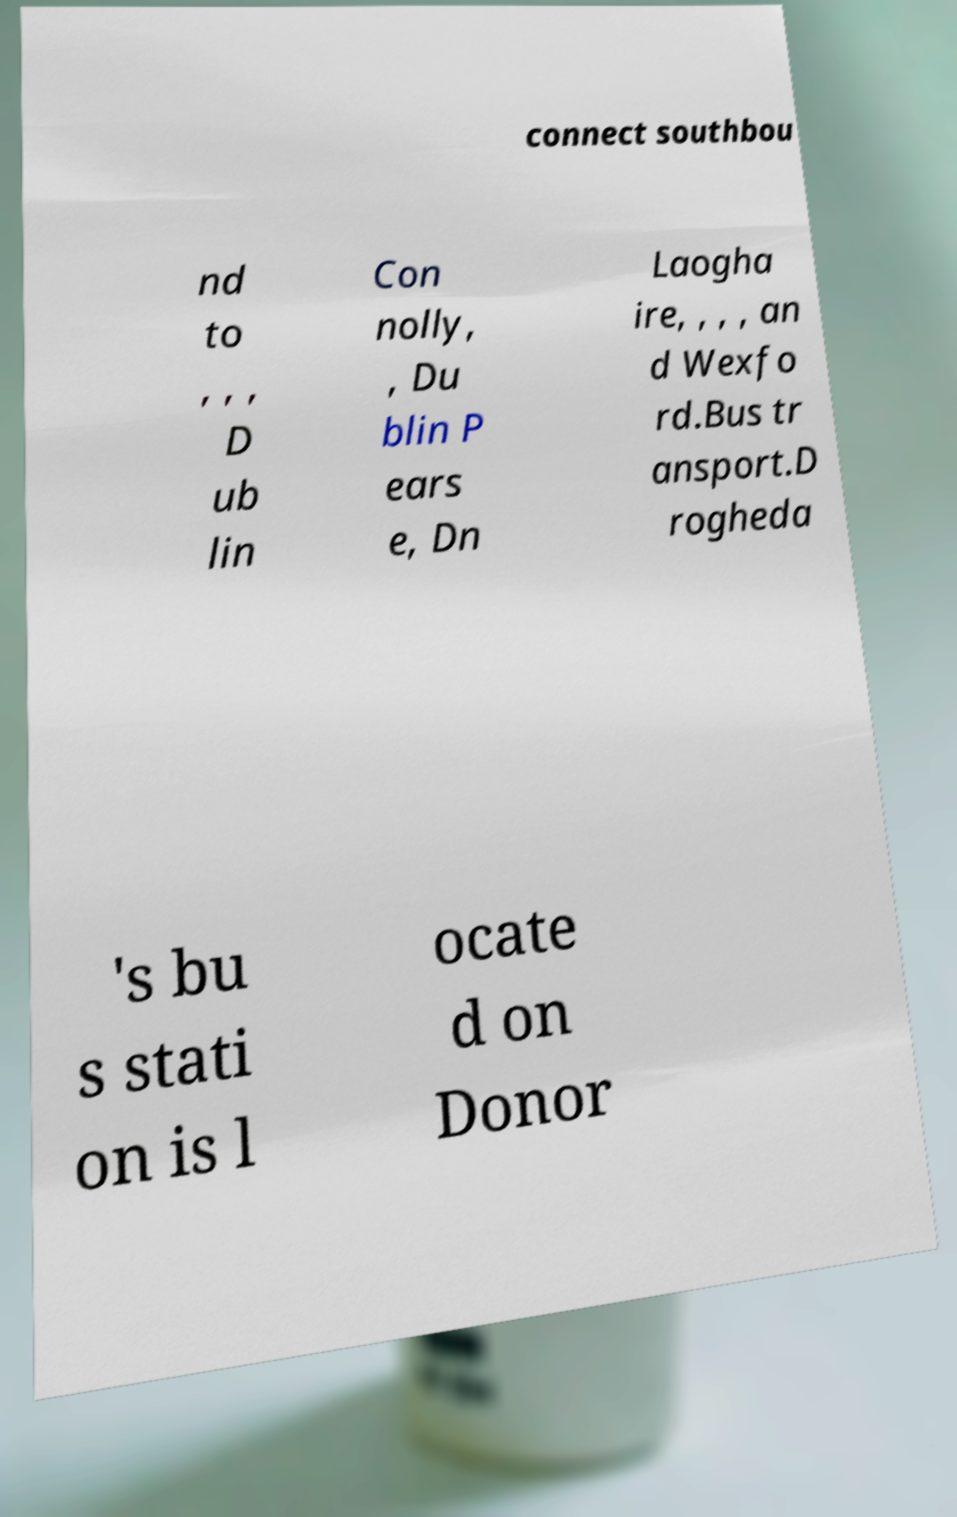What messages or text are displayed in this image? I need them in a readable, typed format. connect southbou nd to , , , D ub lin Con nolly, , Du blin P ears e, Dn Laogha ire, , , , an d Wexfo rd.Bus tr ansport.D rogheda 's bu s stati on is l ocate d on Donor 